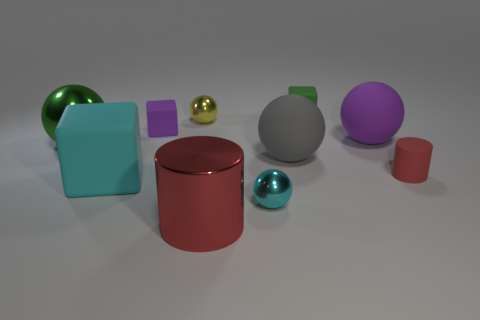Subtract 2 balls. How many balls are left? 3 Subtract all yellow spheres. How many spheres are left? 4 Subtract all green spheres. How many spheres are left? 4 Subtract all red balls. Subtract all yellow cylinders. How many balls are left? 5 Subtract all cylinders. How many objects are left? 8 Add 8 large cyan cylinders. How many large cyan cylinders exist? 8 Subtract 0 blue blocks. How many objects are left? 10 Subtract all yellow shiny spheres. Subtract all brown matte objects. How many objects are left? 9 Add 6 big cylinders. How many big cylinders are left? 7 